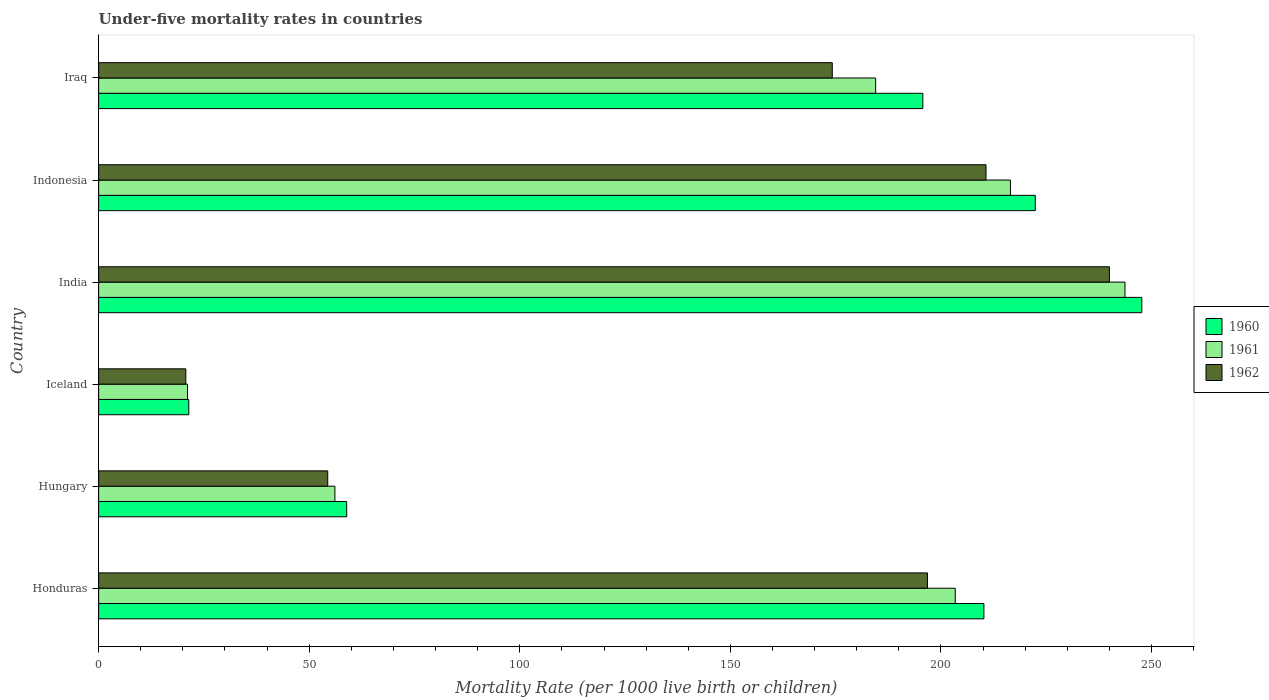How many bars are there on the 2nd tick from the bottom?
Keep it short and to the point. 3. What is the label of the 1st group of bars from the top?
Your response must be concise. Iraq. What is the under-five mortality rate in 1960 in Iraq?
Offer a terse response. 195.7. Across all countries, what is the maximum under-five mortality rate in 1962?
Make the answer very short. 240. Across all countries, what is the minimum under-five mortality rate in 1960?
Keep it short and to the point. 21.4. In which country was the under-five mortality rate in 1960 minimum?
Keep it short and to the point. Iceland. What is the total under-five mortality rate in 1962 in the graph?
Provide a short and direct response. 896.8. What is the difference between the under-five mortality rate in 1962 in Iceland and that in India?
Give a very brief answer. -219.3. What is the difference between the under-five mortality rate in 1962 in India and the under-five mortality rate in 1960 in Honduras?
Your answer should be very brief. 29.8. What is the average under-five mortality rate in 1962 per country?
Offer a very short reply. 149.47. What is the difference between the under-five mortality rate in 1962 and under-five mortality rate in 1961 in Iraq?
Give a very brief answer. -10.3. In how many countries, is the under-five mortality rate in 1962 greater than 40 ?
Offer a very short reply. 5. What is the ratio of the under-five mortality rate in 1960 in Hungary to that in Indonesia?
Provide a succinct answer. 0.26. Is the under-five mortality rate in 1962 in Honduras less than that in India?
Provide a succinct answer. Yes. Is the difference between the under-five mortality rate in 1962 in Hungary and Iraq greater than the difference between the under-five mortality rate in 1961 in Hungary and Iraq?
Offer a terse response. Yes. What is the difference between the highest and the second highest under-five mortality rate in 1962?
Provide a short and direct response. 29.3. What is the difference between the highest and the lowest under-five mortality rate in 1960?
Offer a terse response. 226.3. In how many countries, is the under-five mortality rate in 1960 greater than the average under-five mortality rate in 1960 taken over all countries?
Offer a very short reply. 4. Is the sum of the under-five mortality rate in 1961 in Honduras and India greater than the maximum under-five mortality rate in 1962 across all countries?
Ensure brevity in your answer.  Yes. What does the 2nd bar from the top in India represents?
Give a very brief answer. 1961. What does the 2nd bar from the bottom in Indonesia represents?
Your answer should be compact. 1961. How many countries are there in the graph?
Provide a succinct answer. 6. Are the values on the major ticks of X-axis written in scientific E-notation?
Provide a succinct answer. No. Does the graph contain any zero values?
Your response must be concise. No. Where does the legend appear in the graph?
Provide a succinct answer. Center right. How many legend labels are there?
Your response must be concise. 3. What is the title of the graph?
Give a very brief answer. Under-five mortality rates in countries. What is the label or title of the X-axis?
Your answer should be compact. Mortality Rate (per 1000 live birth or children). What is the Mortality Rate (per 1000 live birth or children) in 1960 in Honduras?
Keep it short and to the point. 210.2. What is the Mortality Rate (per 1000 live birth or children) in 1961 in Honduras?
Provide a succinct answer. 203.4. What is the Mortality Rate (per 1000 live birth or children) in 1962 in Honduras?
Keep it short and to the point. 196.8. What is the Mortality Rate (per 1000 live birth or children) in 1960 in Hungary?
Your response must be concise. 58.9. What is the Mortality Rate (per 1000 live birth or children) of 1961 in Hungary?
Your answer should be very brief. 56.1. What is the Mortality Rate (per 1000 live birth or children) of 1962 in Hungary?
Your response must be concise. 54.4. What is the Mortality Rate (per 1000 live birth or children) in 1960 in Iceland?
Your answer should be very brief. 21.4. What is the Mortality Rate (per 1000 live birth or children) in 1961 in Iceland?
Your answer should be very brief. 21.1. What is the Mortality Rate (per 1000 live birth or children) in 1962 in Iceland?
Keep it short and to the point. 20.7. What is the Mortality Rate (per 1000 live birth or children) of 1960 in India?
Offer a very short reply. 247.7. What is the Mortality Rate (per 1000 live birth or children) of 1961 in India?
Offer a terse response. 243.7. What is the Mortality Rate (per 1000 live birth or children) of 1962 in India?
Provide a short and direct response. 240. What is the Mortality Rate (per 1000 live birth or children) in 1960 in Indonesia?
Your answer should be very brief. 222.4. What is the Mortality Rate (per 1000 live birth or children) in 1961 in Indonesia?
Ensure brevity in your answer.  216.5. What is the Mortality Rate (per 1000 live birth or children) of 1962 in Indonesia?
Provide a succinct answer. 210.7. What is the Mortality Rate (per 1000 live birth or children) of 1960 in Iraq?
Provide a succinct answer. 195.7. What is the Mortality Rate (per 1000 live birth or children) in 1961 in Iraq?
Keep it short and to the point. 184.5. What is the Mortality Rate (per 1000 live birth or children) in 1962 in Iraq?
Provide a short and direct response. 174.2. Across all countries, what is the maximum Mortality Rate (per 1000 live birth or children) in 1960?
Give a very brief answer. 247.7. Across all countries, what is the maximum Mortality Rate (per 1000 live birth or children) in 1961?
Your answer should be very brief. 243.7. Across all countries, what is the maximum Mortality Rate (per 1000 live birth or children) in 1962?
Give a very brief answer. 240. Across all countries, what is the minimum Mortality Rate (per 1000 live birth or children) of 1960?
Provide a succinct answer. 21.4. Across all countries, what is the minimum Mortality Rate (per 1000 live birth or children) in 1961?
Give a very brief answer. 21.1. Across all countries, what is the minimum Mortality Rate (per 1000 live birth or children) in 1962?
Offer a very short reply. 20.7. What is the total Mortality Rate (per 1000 live birth or children) in 1960 in the graph?
Make the answer very short. 956.3. What is the total Mortality Rate (per 1000 live birth or children) of 1961 in the graph?
Your answer should be very brief. 925.3. What is the total Mortality Rate (per 1000 live birth or children) of 1962 in the graph?
Ensure brevity in your answer.  896.8. What is the difference between the Mortality Rate (per 1000 live birth or children) of 1960 in Honduras and that in Hungary?
Make the answer very short. 151.3. What is the difference between the Mortality Rate (per 1000 live birth or children) of 1961 in Honduras and that in Hungary?
Your answer should be compact. 147.3. What is the difference between the Mortality Rate (per 1000 live birth or children) in 1962 in Honduras and that in Hungary?
Keep it short and to the point. 142.4. What is the difference between the Mortality Rate (per 1000 live birth or children) of 1960 in Honduras and that in Iceland?
Your answer should be very brief. 188.8. What is the difference between the Mortality Rate (per 1000 live birth or children) of 1961 in Honduras and that in Iceland?
Your answer should be very brief. 182.3. What is the difference between the Mortality Rate (per 1000 live birth or children) of 1962 in Honduras and that in Iceland?
Your answer should be compact. 176.1. What is the difference between the Mortality Rate (per 1000 live birth or children) in 1960 in Honduras and that in India?
Ensure brevity in your answer.  -37.5. What is the difference between the Mortality Rate (per 1000 live birth or children) in 1961 in Honduras and that in India?
Your answer should be very brief. -40.3. What is the difference between the Mortality Rate (per 1000 live birth or children) in 1962 in Honduras and that in India?
Make the answer very short. -43.2. What is the difference between the Mortality Rate (per 1000 live birth or children) of 1960 in Honduras and that in Indonesia?
Keep it short and to the point. -12.2. What is the difference between the Mortality Rate (per 1000 live birth or children) in 1961 in Honduras and that in Indonesia?
Provide a succinct answer. -13.1. What is the difference between the Mortality Rate (per 1000 live birth or children) of 1961 in Honduras and that in Iraq?
Keep it short and to the point. 18.9. What is the difference between the Mortality Rate (per 1000 live birth or children) in 1962 in Honduras and that in Iraq?
Give a very brief answer. 22.6. What is the difference between the Mortality Rate (per 1000 live birth or children) of 1960 in Hungary and that in Iceland?
Provide a short and direct response. 37.5. What is the difference between the Mortality Rate (per 1000 live birth or children) of 1961 in Hungary and that in Iceland?
Ensure brevity in your answer.  35. What is the difference between the Mortality Rate (per 1000 live birth or children) in 1962 in Hungary and that in Iceland?
Your answer should be compact. 33.7. What is the difference between the Mortality Rate (per 1000 live birth or children) in 1960 in Hungary and that in India?
Provide a short and direct response. -188.8. What is the difference between the Mortality Rate (per 1000 live birth or children) of 1961 in Hungary and that in India?
Provide a short and direct response. -187.6. What is the difference between the Mortality Rate (per 1000 live birth or children) of 1962 in Hungary and that in India?
Ensure brevity in your answer.  -185.6. What is the difference between the Mortality Rate (per 1000 live birth or children) of 1960 in Hungary and that in Indonesia?
Keep it short and to the point. -163.5. What is the difference between the Mortality Rate (per 1000 live birth or children) of 1961 in Hungary and that in Indonesia?
Ensure brevity in your answer.  -160.4. What is the difference between the Mortality Rate (per 1000 live birth or children) in 1962 in Hungary and that in Indonesia?
Provide a succinct answer. -156.3. What is the difference between the Mortality Rate (per 1000 live birth or children) of 1960 in Hungary and that in Iraq?
Offer a terse response. -136.8. What is the difference between the Mortality Rate (per 1000 live birth or children) in 1961 in Hungary and that in Iraq?
Keep it short and to the point. -128.4. What is the difference between the Mortality Rate (per 1000 live birth or children) in 1962 in Hungary and that in Iraq?
Offer a terse response. -119.8. What is the difference between the Mortality Rate (per 1000 live birth or children) of 1960 in Iceland and that in India?
Make the answer very short. -226.3. What is the difference between the Mortality Rate (per 1000 live birth or children) of 1961 in Iceland and that in India?
Offer a very short reply. -222.6. What is the difference between the Mortality Rate (per 1000 live birth or children) of 1962 in Iceland and that in India?
Ensure brevity in your answer.  -219.3. What is the difference between the Mortality Rate (per 1000 live birth or children) in 1960 in Iceland and that in Indonesia?
Keep it short and to the point. -201. What is the difference between the Mortality Rate (per 1000 live birth or children) in 1961 in Iceland and that in Indonesia?
Your answer should be very brief. -195.4. What is the difference between the Mortality Rate (per 1000 live birth or children) of 1962 in Iceland and that in Indonesia?
Provide a short and direct response. -190. What is the difference between the Mortality Rate (per 1000 live birth or children) in 1960 in Iceland and that in Iraq?
Make the answer very short. -174.3. What is the difference between the Mortality Rate (per 1000 live birth or children) in 1961 in Iceland and that in Iraq?
Keep it short and to the point. -163.4. What is the difference between the Mortality Rate (per 1000 live birth or children) in 1962 in Iceland and that in Iraq?
Keep it short and to the point. -153.5. What is the difference between the Mortality Rate (per 1000 live birth or children) in 1960 in India and that in Indonesia?
Ensure brevity in your answer.  25.3. What is the difference between the Mortality Rate (per 1000 live birth or children) of 1961 in India and that in Indonesia?
Give a very brief answer. 27.2. What is the difference between the Mortality Rate (per 1000 live birth or children) of 1962 in India and that in Indonesia?
Offer a terse response. 29.3. What is the difference between the Mortality Rate (per 1000 live birth or children) of 1961 in India and that in Iraq?
Offer a very short reply. 59.2. What is the difference between the Mortality Rate (per 1000 live birth or children) in 1962 in India and that in Iraq?
Your answer should be compact. 65.8. What is the difference between the Mortality Rate (per 1000 live birth or children) in 1960 in Indonesia and that in Iraq?
Provide a short and direct response. 26.7. What is the difference between the Mortality Rate (per 1000 live birth or children) of 1962 in Indonesia and that in Iraq?
Offer a terse response. 36.5. What is the difference between the Mortality Rate (per 1000 live birth or children) in 1960 in Honduras and the Mortality Rate (per 1000 live birth or children) in 1961 in Hungary?
Your answer should be very brief. 154.1. What is the difference between the Mortality Rate (per 1000 live birth or children) in 1960 in Honduras and the Mortality Rate (per 1000 live birth or children) in 1962 in Hungary?
Your answer should be very brief. 155.8. What is the difference between the Mortality Rate (per 1000 live birth or children) of 1961 in Honduras and the Mortality Rate (per 1000 live birth or children) of 1962 in Hungary?
Ensure brevity in your answer.  149. What is the difference between the Mortality Rate (per 1000 live birth or children) of 1960 in Honduras and the Mortality Rate (per 1000 live birth or children) of 1961 in Iceland?
Your response must be concise. 189.1. What is the difference between the Mortality Rate (per 1000 live birth or children) of 1960 in Honduras and the Mortality Rate (per 1000 live birth or children) of 1962 in Iceland?
Keep it short and to the point. 189.5. What is the difference between the Mortality Rate (per 1000 live birth or children) in 1961 in Honduras and the Mortality Rate (per 1000 live birth or children) in 1962 in Iceland?
Your answer should be very brief. 182.7. What is the difference between the Mortality Rate (per 1000 live birth or children) in 1960 in Honduras and the Mortality Rate (per 1000 live birth or children) in 1961 in India?
Offer a very short reply. -33.5. What is the difference between the Mortality Rate (per 1000 live birth or children) in 1960 in Honduras and the Mortality Rate (per 1000 live birth or children) in 1962 in India?
Your answer should be very brief. -29.8. What is the difference between the Mortality Rate (per 1000 live birth or children) in 1961 in Honduras and the Mortality Rate (per 1000 live birth or children) in 1962 in India?
Offer a terse response. -36.6. What is the difference between the Mortality Rate (per 1000 live birth or children) in 1960 in Honduras and the Mortality Rate (per 1000 live birth or children) in 1962 in Indonesia?
Make the answer very short. -0.5. What is the difference between the Mortality Rate (per 1000 live birth or children) in 1960 in Honduras and the Mortality Rate (per 1000 live birth or children) in 1961 in Iraq?
Give a very brief answer. 25.7. What is the difference between the Mortality Rate (per 1000 live birth or children) in 1961 in Honduras and the Mortality Rate (per 1000 live birth or children) in 1962 in Iraq?
Provide a short and direct response. 29.2. What is the difference between the Mortality Rate (per 1000 live birth or children) in 1960 in Hungary and the Mortality Rate (per 1000 live birth or children) in 1961 in Iceland?
Your answer should be very brief. 37.8. What is the difference between the Mortality Rate (per 1000 live birth or children) of 1960 in Hungary and the Mortality Rate (per 1000 live birth or children) of 1962 in Iceland?
Give a very brief answer. 38.2. What is the difference between the Mortality Rate (per 1000 live birth or children) in 1961 in Hungary and the Mortality Rate (per 1000 live birth or children) in 1962 in Iceland?
Ensure brevity in your answer.  35.4. What is the difference between the Mortality Rate (per 1000 live birth or children) of 1960 in Hungary and the Mortality Rate (per 1000 live birth or children) of 1961 in India?
Provide a succinct answer. -184.8. What is the difference between the Mortality Rate (per 1000 live birth or children) of 1960 in Hungary and the Mortality Rate (per 1000 live birth or children) of 1962 in India?
Your answer should be compact. -181.1. What is the difference between the Mortality Rate (per 1000 live birth or children) in 1961 in Hungary and the Mortality Rate (per 1000 live birth or children) in 1962 in India?
Make the answer very short. -183.9. What is the difference between the Mortality Rate (per 1000 live birth or children) of 1960 in Hungary and the Mortality Rate (per 1000 live birth or children) of 1961 in Indonesia?
Your answer should be very brief. -157.6. What is the difference between the Mortality Rate (per 1000 live birth or children) in 1960 in Hungary and the Mortality Rate (per 1000 live birth or children) in 1962 in Indonesia?
Provide a short and direct response. -151.8. What is the difference between the Mortality Rate (per 1000 live birth or children) in 1961 in Hungary and the Mortality Rate (per 1000 live birth or children) in 1962 in Indonesia?
Offer a very short reply. -154.6. What is the difference between the Mortality Rate (per 1000 live birth or children) of 1960 in Hungary and the Mortality Rate (per 1000 live birth or children) of 1961 in Iraq?
Make the answer very short. -125.6. What is the difference between the Mortality Rate (per 1000 live birth or children) of 1960 in Hungary and the Mortality Rate (per 1000 live birth or children) of 1962 in Iraq?
Keep it short and to the point. -115.3. What is the difference between the Mortality Rate (per 1000 live birth or children) of 1961 in Hungary and the Mortality Rate (per 1000 live birth or children) of 1962 in Iraq?
Your answer should be very brief. -118.1. What is the difference between the Mortality Rate (per 1000 live birth or children) of 1960 in Iceland and the Mortality Rate (per 1000 live birth or children) of 1961 in India?
Your answer should be compact. -222.3. What is the difference between the Mortality Rate (per 1000 live birth or children) in 1960 in Iceland and the Mortality Rate (per 1000 live birth or children) in 1962 in India?
Offer a very short reply. -218.6. What is the difference between the Mortality Rate (per 1000 live birth or children) in 1961 in Iceland and the Mortality Rate (per 1000 live birth or children) in 1962 in India?
Keep it short and to the point. -218.9. What is the difference between the Mortality Rate (per 1000 live birth or children) in 1960 in Iceland and the Mortality Rate (per 1000 live birth or children) in 1961 in Indonesia?
Your response must be concise. -195.1. What is the difference between the Mortality Rate (per 1000 live birth or children) in 1960 in Iceland and the Mortality Rate (per 1000 live birth or children) in 1962 in Indonesia?
Provide a succinct answer. -189.3. What is the difference between the Mortality Rate (per 1000 live birth or children) in 1961 in Iceland and the Mortality Rate (per 1000 live birth or children) in 1962 in Indonesia?
Make the answer very short. -189.6. What is the difference between the Mortality Rate (per 1000 live birth or children) in 1960 in Iceland and the Mortality Rate (per 1000 live birth or children) in 1961 in Iraq?
Keep it short and to the point. -163.1. What is the difference between the Mortality Rate (per 1000 live birth or children) of 1960 in Iceland and the Mortality Rate (per 1000 live birth or children) of 1962 in Iraq?
Your answer should be very brief. -152.8. What is the difference between the Mortality Rate (per 1000 live birth or children) of 1961 in Iceland and the Mortality Rate (per 1000 live birth or children) of 1962 in Iraq?
Offer a terse response. -153.1. What is the difference between the Mortality Rate (per 1000 live birth or children) of 1960 in India and the Mortality Rate (per 1000 live birth or children) of 1961 in Indonesia?
Ensure brevity in your answer.  31.2. What is the difference between the Mortality Rate (per 1000 live birth or children) in 1960 in India and the Mortality Rate (per 1000 live birth or children) in 1961 in Iraq?
Your answer should be very brief. 63.2. What is the difference between the Mortality Rate (per 1000 live birth or children) in 1960 in India and the Mortality Rate (per 1000 live birth or children) in 1962 in Iraq?
Provide a succinct answer. 73.5. What is the difference between the Mortality Rate (per 1000 live birth or children) of 1961 in India and the Mortality Rate (per 1000 live birth or children) of 1962 in Iraq?
Ensure brevity in your answer.  69.5. What is the difference between the Mortality Rate (per 1000 live birth or children) of 1960 in Indonesia and the Mortality Rate (per 1000 live birth or children) of 1961 in Iraq?
Your answer should be compact. 37.9. What is the difference between the Mortality Rate (per 1000 live birth or children) of 1960 in Indonesia and the Mortality Rate (per 1000 live birth or children) of 1962 in Iraq?
Your response must be concise. 48.2. What is the difference between the Mortality Rate (per 1000 live birth or children) of 1961 in Indonesia and the Mortality Rate (per 1000 live birth or children) of 1962 in Iraq?
Give a very brief answer. 42.3. What is the average Mortality Rate (per 1000 live birth or children) in 1960 per country?
Offer a very short reply. 159.38. What is the average Mortality Rate (per 1000 live birth or children) of 1961 per country?
Provide a short and direct response. 154.22. What is the average Mortality Rate (per 1000 live birth or children) in 1962 per country?
Keep it short and to the point. 149.47. What is the difference between the Mortality Rate (per 1000 live birth or children) of 1960 and Mortality Rate (per 1000 live birth or children) of 1961 in Honduras?
Offer a very short reply. 6.8. What is the difference between the Mortality Rate (per 1000 live birth or children) of 1960 and Mortality Rate (per 1000 live birth or children) of 1962 in Hungary?
Your answer should be very brief. 4.5. What is the difference between the Mortality Rate (per 1000 live birth or children) of 1960 and Mortality Rate (per 1000 live birth or children) of 1961 in Iceland?
Your response must be concise. 0.3. What is the difference between the Mortality Rate (per 1000 live birth or children) in 1960 and Mortality Rate (per 1000 live birth or children) in 1962 in Iceland?
Offer a very short reply. 0.7. What is the difference between the Mortality Rate (per 1000 live birth or children) in 1960 and Mortality Rate (per 1000 live birth or children) in 1961 in India?
Keep it short and to the point. 4. What is the difference between the Mortality Rate (per 1000 live birth or children) in 1960 and Mortality Rate (per 1000 live birth or children) in 1962 in India?
Keep it short and to the point. 7.7. What is the difference between the Mortality Rate (per 1000 live birth or children) in 1960 and Mortality Rate (per 1000 live birth or children) in 1961 in Indonesia?
Give a very brief answer. 5.9. What is the difference between the Mortality Rate (per 1000 live birth or children) in 1960 and Mortality Rate (per 1000 live birth or children) in 1961 in Iraq?
Make the answer very short. 11.2. What is the difference between the Mortality Rate (per 1000 live birth or children) of 1961 and Mortality Rate (per 1000 live birth or children) of 1962 in Iraq?
Your response must be concise. 10.3. What is the ratio of the Mortality Rate (per 1000 live birth or children) in 1960 in Honduras to that in Hungary?
Provide a succinct answer. 3.57. What is the ratio of the Mortality Rate (per 1000 live birth or children) in 1961 in Honduras to that in Hungary?
Offer a very short reply. 3.63. What is the ratio of the Mortality Rate (per 1000 live birth or children) in 1962 in Honduras to that in Hungary?
Offer a terse response. 3.62. What is the ratio of the Mortality Rate (per 1000 live birth or children) in 1960 in Honduras to that in Iceland?
Make the answer very short. 9.82. What is the ratio of the Mortality Rate (per 1000 live birth or children) in 1961 in Honduras to that in Iceland?
Your answer should be compact. 9.64. What is the ratio of the Mortality Rate (per 1000 live birth or children) of 1962 in Honduras to that in Iceland?
Ensure brevity in your answer.  9.51. What is the ratio of the Mortality Rate (per 1000 live birth or children) in 1960 in Honduras to that in India?
Provide a short and direct response. 0.85. What is the ratio of the Mortality Rate (per 1000 live birth or children) of 1961 in Honduras to that in India?
Make the answer very short. 0.83. What is the ratio of the Mortality Rate (per 1000 live birth or children) in 1962 in Honduras to that in India?
Provide a succinct answer. 0.82. What is the ratio of the Mortality Rate (per 1000 live birth or children) in 1960 in Honduras to that in Indonesia?
Your answer should be very brief. 0.95. What is the ratio of the Mortality Rate (per 1000 live birth or children) in 1961 in Honduras to that in Indonesia?
Make the answer very short. 0.94. What is the ratio of the Mortality Rate (per 1000 live birth or children) in 1962 in Honduras to that in Indonesia?
Offer a terse response. 0.93. What is the ratio of the Mortality Rate (per 1000 live birth or children) of 1960 in Honduras to that in Iraq?
Ensure brevity in your answer.  1.07. What is the ratio of the Mortality Rate (per 1000 live birth or children) of 1961 in Honduras to that in Iraq?
Ensure brevity in your answer.  1.1. What is the ratio of the Mortality Rate (per 1000 live birth or children) in 1962 in Honduras to that in Iraq?
Your answer should be very brief. 1.13. What is the ratio of the Mortality Rate (per 1000 live birth or children) of 1960 in Hungary to that in Iceland?
Make the answer very short. 2.75. What is the ratio of the Mortality Rate (per 1000 live birth or children) in 1961 in Hungary to that in Iceland?
Provide a succinct answer. 2.66. What is the ratio of the Mortality Rate (per 1000 live birth or children) in 1962 in Hungary to that in Iceland?
Your response must be concise. 2.63. What is the ratio of the Mortality Rate (per 1000 live birth or children) of 1960 in Hungary to that in India?
Offer a very short reply. 0.24. What is the ratio of the Mortality Rate (per 1000 live birth or children) of 1961 in Hungary to that in India?
Your answer should be very brief. 0.23. What is the ratio of the Mortality Rate (per 1000 live birth or children) in 1962 in Hungary to that in India?
Your answer should be very brief. 0.23. What is the ratio of the Mortality Rate (per 1000 live birth or children) in 1960 in Hungary to that in Indonesia?
Ensure brevity in your answer.  0.26. What is the ratio of the Mortality Rate (per 1000 live birth or children) of 1961 in Hungary to that in Indonesia?
Make the answer very short. 0.26. What is the ratio of the Mortality Rate (per 1000 live birth or children) in 1962 in Hungary to that in Indonesia?
Give a very brief answer. 0.26. What is the ratio of the Mortality Rate (per 1000 live birth or children) of 1960 in Hungary to that in Iraq?
Provide a short and direct response. 0.3. What is the ratio of the Mortality Rate (per 1000 live birth or children) of 1961 in Hungary to that in Iraq?
Offer a terse response. 0.3. What is the ratio of the Mortality Rate (per 1000 live birth or children) in 1962 in Hungary to that in Iraq?
Give a very brief answer. 0.31. What is the ratio of the Mortality Rate (per 1000 live birth or children) of 1960 in Iceland to that in India?
Provide a short and direct response. 0.09. What is the ratio of the Mortality Rate (per 1000 live birth or children) of 1961 in Iceland to that in India?
Give a very brief answer. 0.09. What is the ratio of the Mortality Rate (per 1000 live birth or children) of 1962 in Iceland to that in India?
Your answer should be very brief. 0.09. What is the ratio of the Mortality Rate (per 1000 live birth or children) of 1960 in Iceland to that in Indonesia?
Your answer should be compact. 0.1. What is the ratio of the Mortality Rate (per 1000 live birth or children) in 1961 in Iceland to that in Indonesia?
Provide a succinct answer. 0.1. What is the ratio of the Mortality Rate (per 1000 live birth or children) in 1962 in Iceland to that in Indonesia?
Ensure brevity in your answer.  0.1. What is the ratio of the Mortality Rate (per 1000 live birth or children) in 1960 in Iceland to that in Iraq?
Make the answer very short. 0.11. What is the ratio of the Mortality Rate (per 1000 live birth or children) of 1961 in Iceland to that in Iraq?
Offer a terse response. 0.11. What is the ratio of the Mortality Rate (per 1000 live birth or children) of 1962 in Iceland to that in Iraq?
Offer a very short reply. 0.12. What is the ratio of the Mortality Rate (per 1000 live birth or children) of 1960 in India to that in Indonesia?
Provide a succinct answer. 1.11. What is the ratio of the Mortality Rate (per 1000 live birth or children) in 1961 in India to that in Indonesia?
Offer a very short reply. 1.13. What is the ratio of the Mortality Rate (per 1000 live birth or children) in 1962 in India to that in Indonesia?
Make the answer very short. 1.14. What is the ratio of the Mortality Rate (per 1000 live birth or children) of 1960 in India to that in Iraq?
Offer a very short reply. 1.27. What is the ratio of the Mortality Rate (per 1000 live birth or children) in 1961 in India to that in Iraq?
Give a very brief answer. 1.32. What is the ratio of the Mortality Rate (per 1000 live birth or children) of 1962 in India to that in Iraq?
Your answer should be compact. 1.38. What is the ratio of the Mortality Rate (per 1000 live birth or children) in 1960 in Indonesia to that in Iraq?
Your answer should be compact. 1.14. What is the ratio of the Mortality Rate (per 1000 live birth or children) of 1961 in Indonesia to that in Iraq?
Make the answer very short. 1.17. What is the ratio of the Mortality Rate (per 1000 live birth or children) of 1962 in Indonesia to that in Iraq?
Make the answer very short. 1.21. What is the difference between the highest and the second highest Mortality Rate (per 1000 live birth or children) of 1960?
Ensure brevity in your answer.  25.3. What is the difference between the highest and the second highest Mortality Rate (per 1000 live birth or children) in 1961?
Offer a terse response. 27.2. What is the difference between the highest and the second highest Mortality Rate (per 1000 live birth or children) in 1962?
Ensure brevity in your answer.  29.3. What is the difference between the highest and the lowest Mortality Rate (per 1000 live birth or children) of 1960?
Provide a succinct answer. 226.3. What is the difference between the highest and the lowest Mortality Rate (per 1000 live birth or children) in 1961?
Provide a succinct answer. 222.6. What is the difference between the highest and the lowest Mortality Rate (per 1000 live birth or children) in 1962?
Provide a succinct answer. 219.3. 